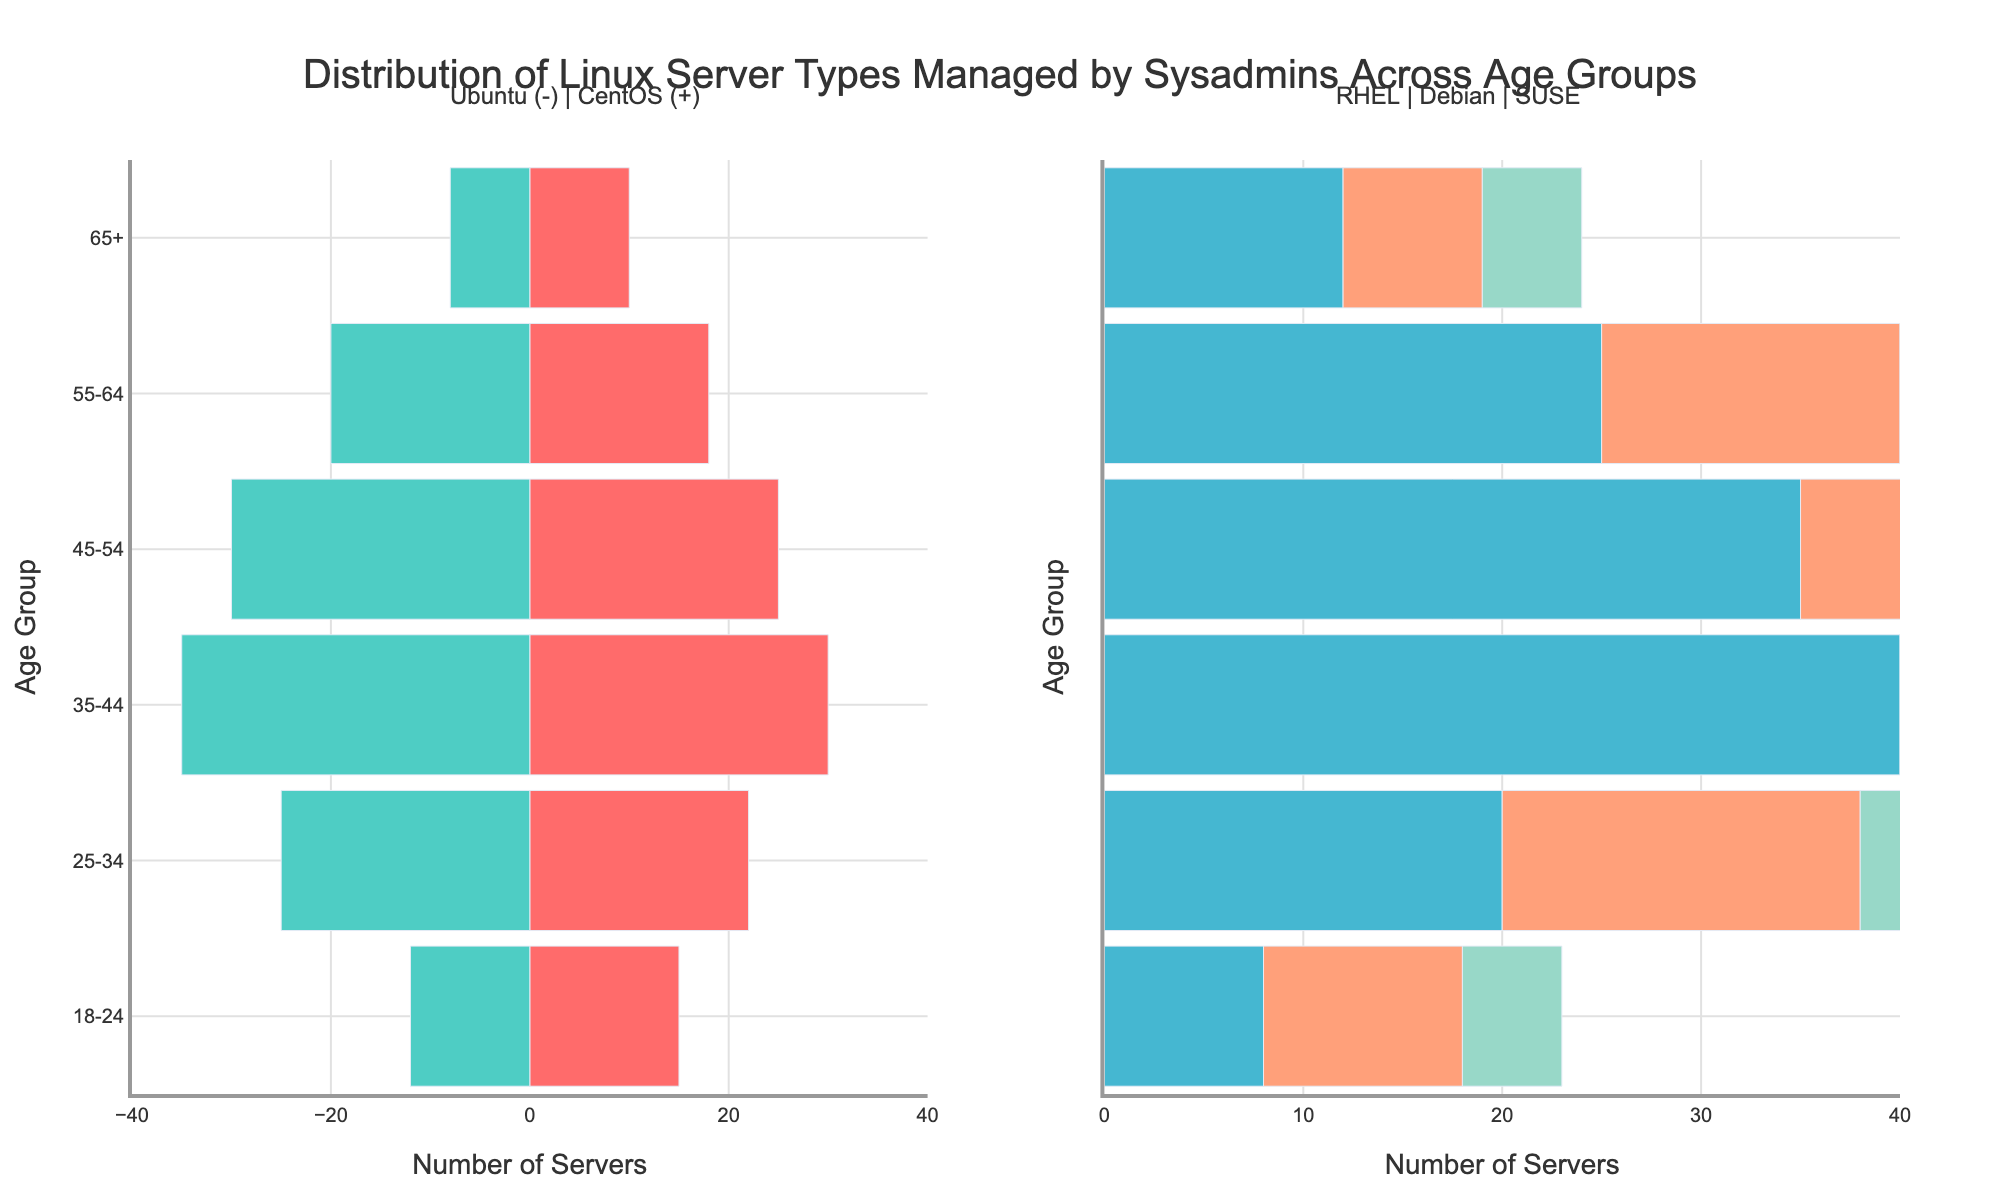Which age group uses Ubuntu the most? The bar for Ubuntu in the age group 35-44 is the longest compared to other age groups in the left subplot.
Answer: 35-44 What is the total number of servers managed by the age group 25-34 across all server types? Sum the number of servers for Ubuntu (22), CentOS (25), Red Hat Enterprise Linux (20), Debian (18), and SUSE Linux Enterprise Server (15): 22 + 25 + 20 + 18 + 15 = 100.
Answer: 100 Which age group has the smallest number of SUSE Linux Enterprise Server users? The bar for SUSE Linux Enterprise Server in the age group 65+ is the shortest in the right subplot.
Answer: 65+ How does the number of CentOS servers managed by the age group 45-54 compare to those managed by the age group 55-64? The length of the bar for CentOS in the age group 45-54 is longer than that for 55-64.
Answer: 45-54 manages more Which server type has the smallest number of users in the age group 18-24? Among the server types for the age group 18-24, the shortest bar on either subplot corresponds to SUSE Linux Enterprise Server (5 servers).
Answer: SUSE Linux Enterprise Server For the age group 35-44, what is the difference between the number of Red Hat Enterprise Linux servers and Debian servers managed? Subtract the number of Debian servers (25) from the number of Red Hat Enterprise Linux servers (40): 40 - 25 = 15.
Answer: 15 Which server type is more popular among sysadmins aged 55-64: Ubuntu or Debian? By comparing the bars in the left and right subplots for the age group 55-64, the bar for Debian (15) is shorter than for Ubuntu (18).
Answer: Ubuntu What is the distribution pattern of Ubuntu servers across the age groups? The length of the bars for Ubuntu generally decreases as the age groups increase from 35-44 onwards, except for a slight increase in the 45-54 group compared to 55-64.
Answer: Primarily decreasing with age How many more servers are managed by the age group 45-54 compared to the 65+ age group for all server types combined? Sum the servers for 45-54 (25+30+35+22+18 = 130) and for 65+ (10+8+12+7+5 = 42), then subtract: 130 - 42 = 88.
Answer: 88 Which server type is the most evenly distributed across all age groups? By visually comparing the bars' lengths in both subplots, Red Hat Enterprise Linux appears to have relatively consistent bar lengths across all age groups.
Answer: Red Hat Enterprise Linux 